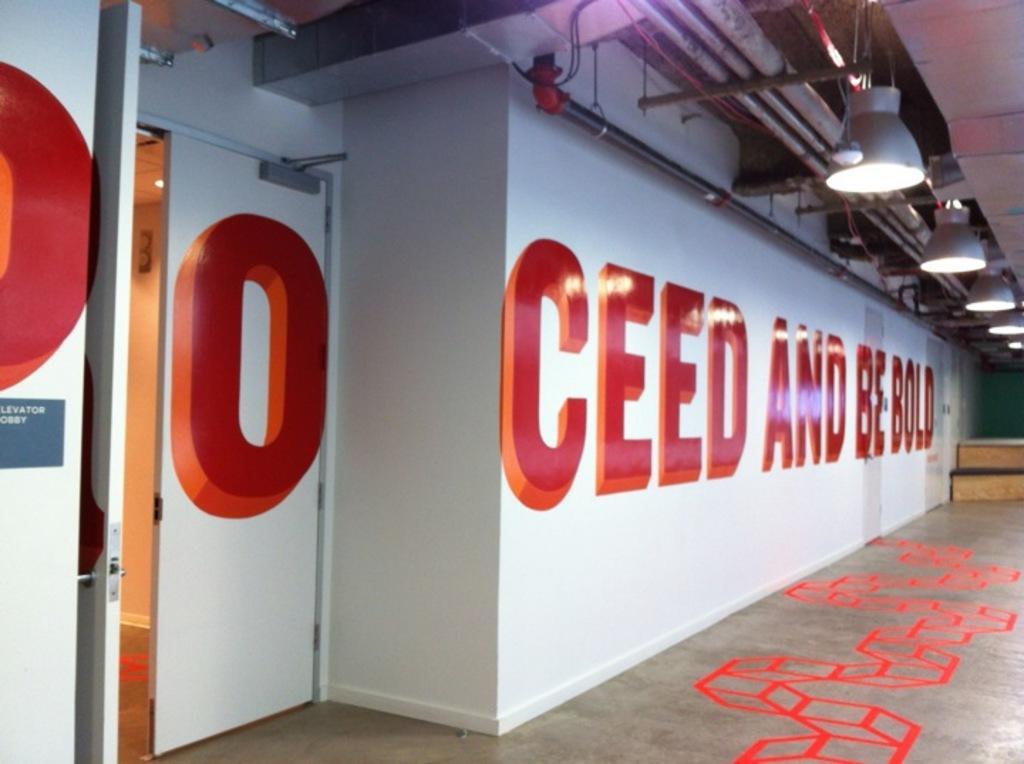Please provide a concise description of this image. In this image there is a floor with some red paintings and beside that there is a wall and lights on the roof. 